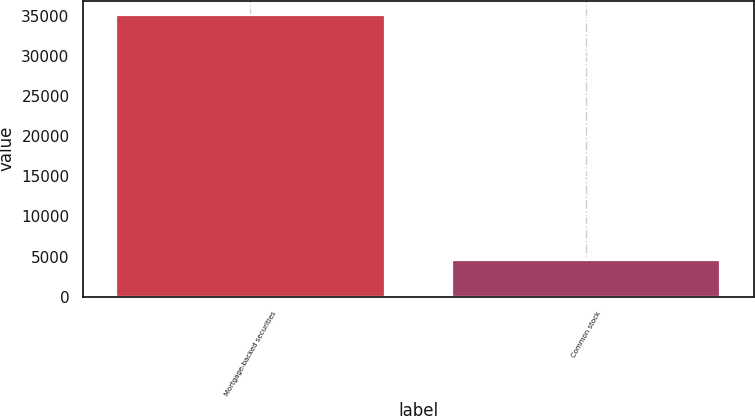<chart> <loc_0><loc_0><loc_500><loc_500><bar_chart><fcel>Mortgage-backed securities<fcel>Common stock<nl><fcel>35084<fcel>4547<nl></chart> 